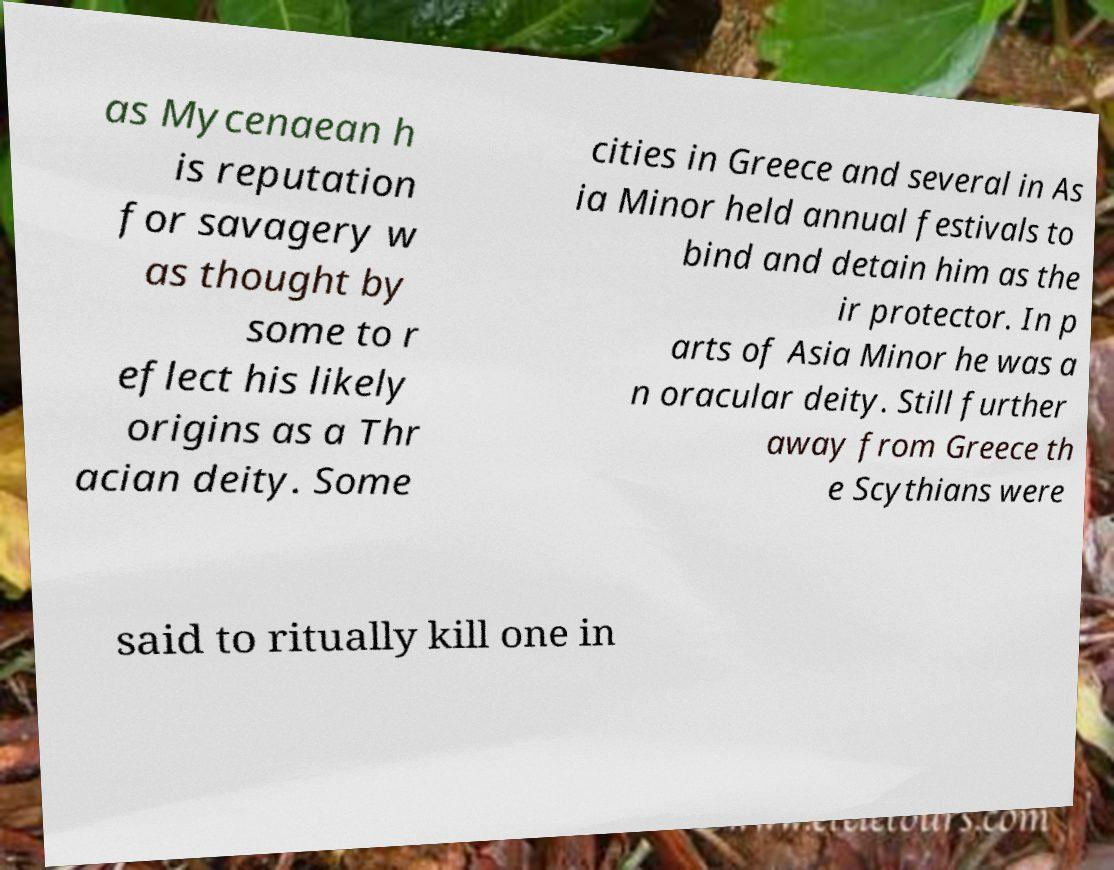Please identify and transcribe the text found in this image. as Mycenaean h is reputation for savagery w as thought by some to r eflect his likely origins as a Thr acian deity. Some cities in Greece and several in As ia Minor held annual festivals to bind and detain him as the ir protector. In p arts of Asia Minor he was a n oracular deity. Still further away from Greece th e Scythians were said to ritually kill one in 